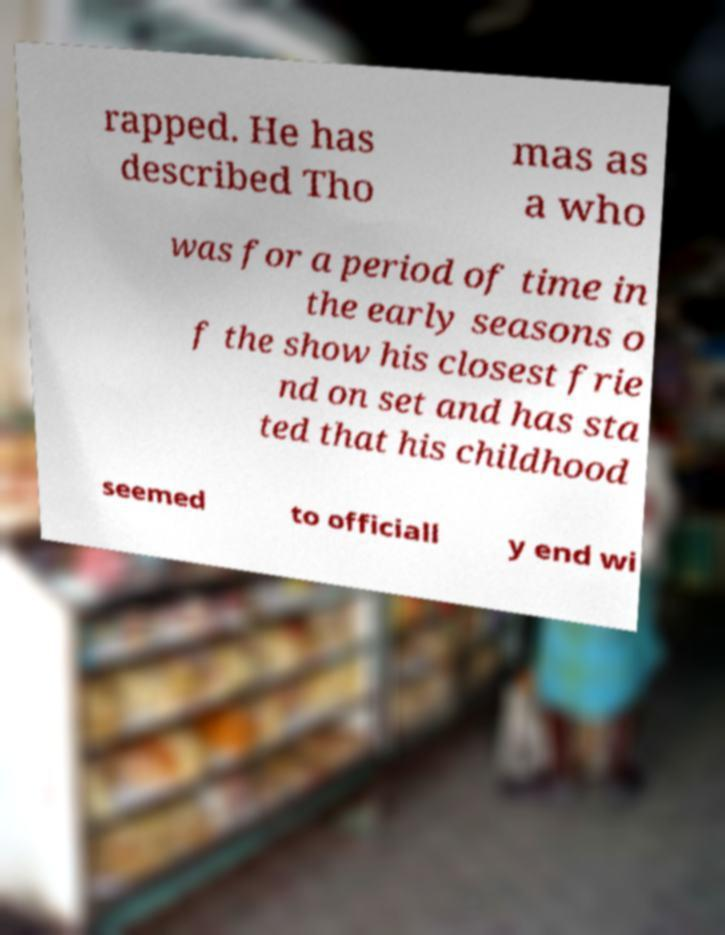For documentation purposes, I need the text within this image transcribed. Could you provide that? rapped. He has described Tho mas as a who was for a period of time in the early seasons o f the show his closest frie nd on set and has sta ted that his childhood seemed to officiall y end wi 